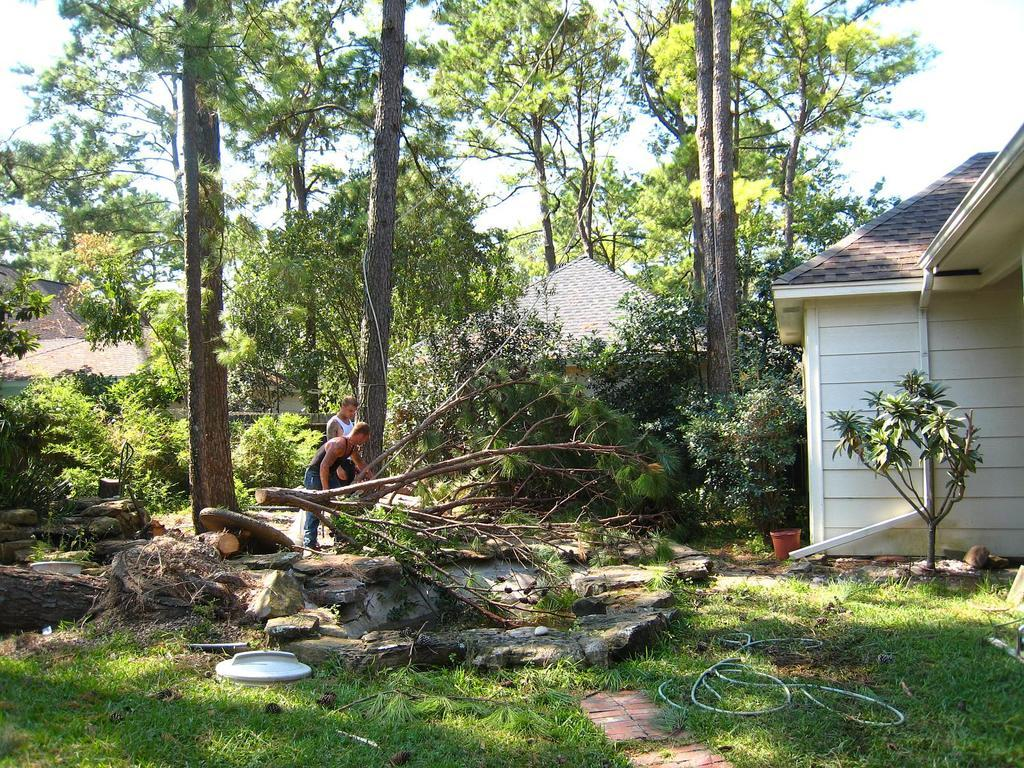How many people are in the image? There are two men in the image. What are the men doing in the image? The men are cutting trees. What type of vegetation is visible at the bottom of the image? There is green grass at the bottom of the image. What can be seen in the background of the image? There are many trees in the background of the image. What structure is located to the right of the image? There is a house to the right of the image. What type of waste is being disposed of by the fowl in the image? There is no fowl or waste present in the image. What type of judgment is the judge making in the image? There is no judge present in the image. 